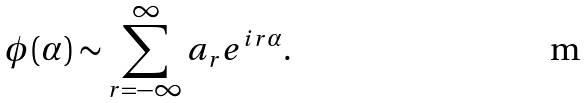Convert formula to latex. <formula><loc_0><loc_0><loc_500><loc_500>\phi ( \alpha ) \sim \sum _ { r = - \infty } ^ { \infty } a _ { r } e ^ { i r \alpha } .</formula> 